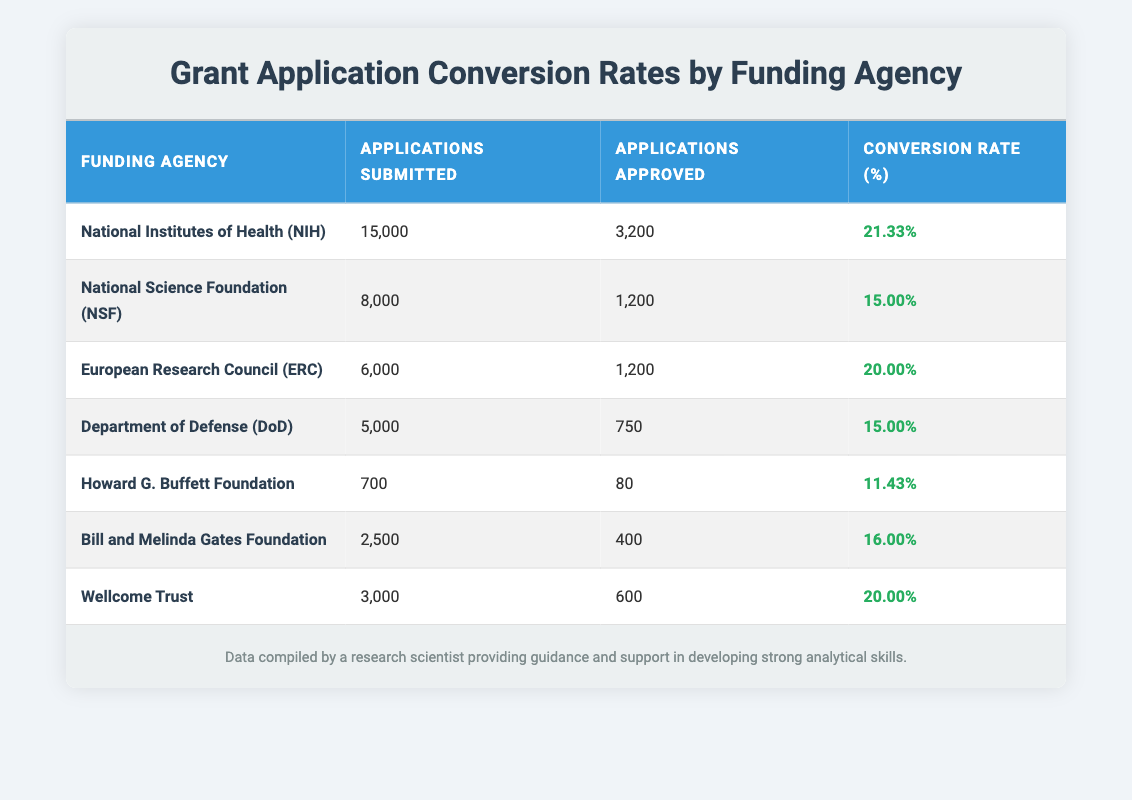What is the highest conversion rate among the funding agencies? The highest conversion rate can be found by comparing all the conversion rates listed in the table. After examining the values, the National Institutes of Health (NIH) has the highest conversion rate of 21.33%.
Answer: 21.33% How many applications were submitted to the National Science Foundation (NSF)? The table provides information about the applications submitted to each funding agency. According to the table, the National Science Foundation (NSF) had 8,000 applications submitted.
Answer: 8,000 Which funding agency had a conversion rate of 15%? To find this, I need to look at the conversion rates listed for each funding agency. The National Science Foundation (NSF) and the Department of Defense (DoD) both have a conversion rate of 15%.
Answer: National Science Foundation (NSF) and Department of Defense (DoD) What is the total number of applications approved by Wellcome Trust and the Howard G. Buffett Foundation combined? The number of applications approved for Wellcome Trust is 600 and for the Howard G. Buffett Foundation is 80. Adding these together gives 600 + 80 = 680 approved applications.
Answer: 680 Is the conversion rate for the Bill and Melinda Gates Foundation higher than that of the Department of Defense (DoD)? The conversion rate for the Bill and Melinda Gates Foundation is 16.00%, while that for the Department of Defense (DoD) is 15.00%. Since 16.00% is greater than 15.00%, the statement is true.
Answer: Yes What is the average conversion rate for all the funding agencies listed in the table? To calculate the average conversion rate, I first sum the individual rates: 21.33 + 15.00 + 20.00 + 15.00 + 11.43 + 16.00 + 20.00 = 118.76. Then, I divide by the number of agencies (7), which gives 118.76 / 7 ≈ 16.96. Therefore, the average conversion rate is approximately 16.96%.
Answer: 16.96% Which agency had the least number of applications submitted? I need to compare the total applications submitted across all agencies. The Howard G. Buffett Foundation had the least number of applications submitted at 700.
Answer: Howard G. Buffett Foundation What is the difference in conversion rate between the NIH and the ERC? The conversion rate for NIH is 21.33% and for ERC is 20.00%. The difference can be calculated as 21.33% - 20.00% = 1.33%. Therefore, the difference in conversion rates is 1.33%.
Answer: 1.33% What percentage of applications were approved by the Department of Defense (DoD)? To find this percentage, I take the number of applications approved (750) and divide it by the applications submitted (5,000), which gives 750 / 5000 = 0.15 or 15%. Thus, the percentage of applications approved is 15%.
Answer: 15% 